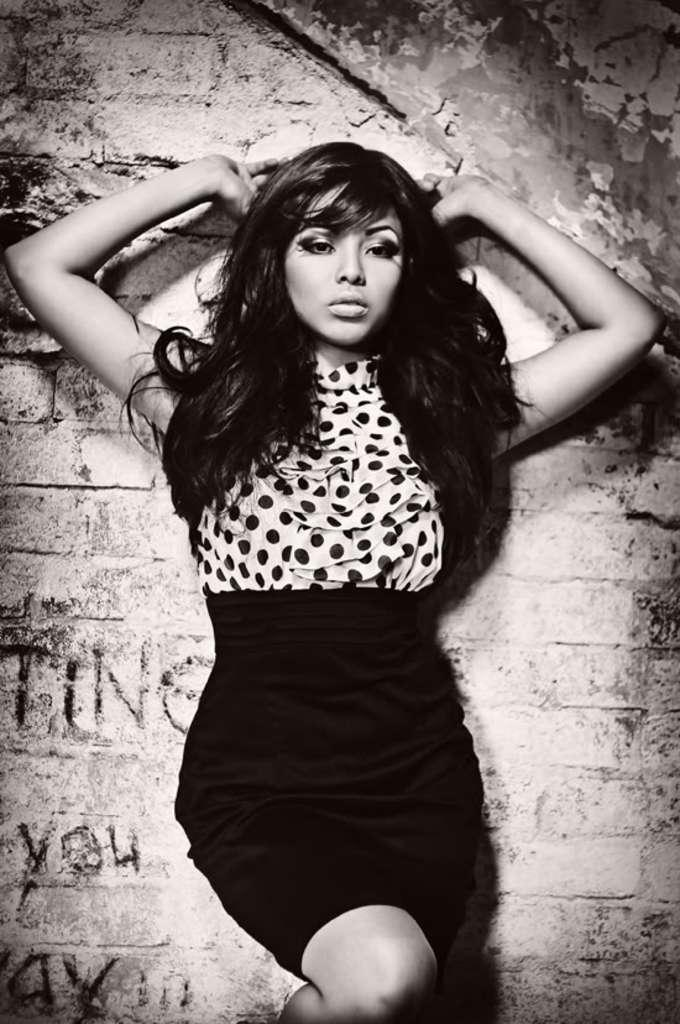Who is the main subject in the image? There is a woman in the middle of the image. What can be seen behind the woman? There is a wall visible behind the woman. What color scheme is used in the image? The image is in black and white. What type of grape is the woman holding in the image? There is no grape present in the image; the woman is not holding any object. 